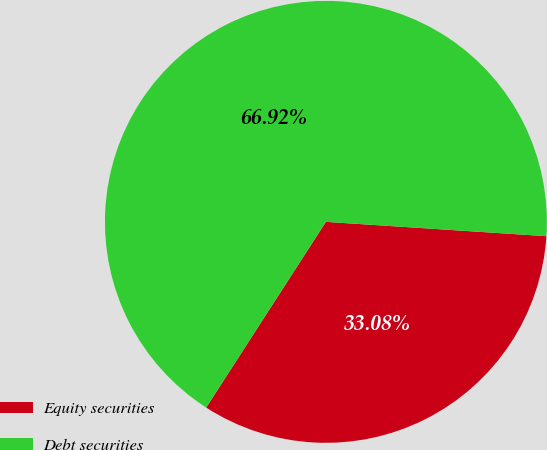<chart> <loc_0><loc_0><loc_500><loc_500><pie_chart><fcel>Equity securities<fcel>Debt securities<nl><fcel>33.08%<fcel>66.92%<nl></chart> 